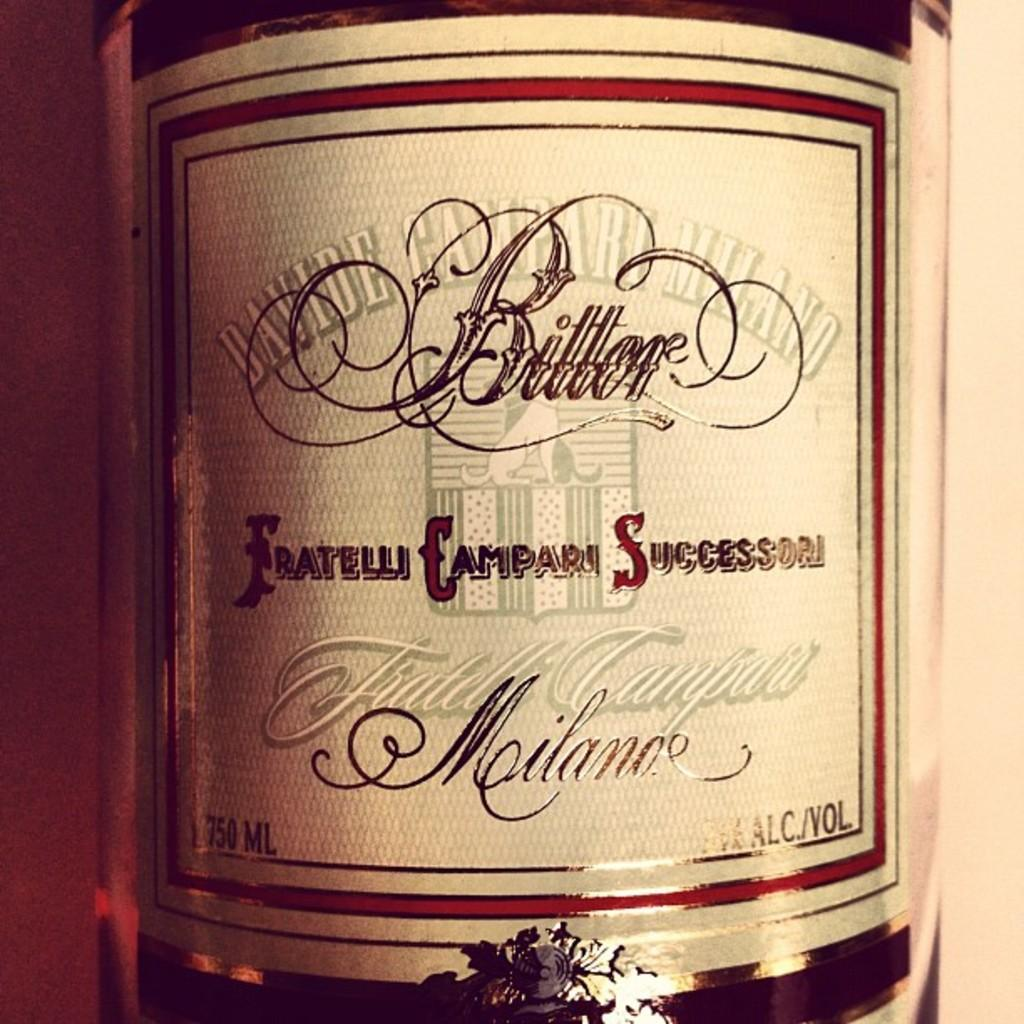<image>
Create a compact narrative representing the image presented. A bottle of Fratelli Campari Successori has a very plain label. 